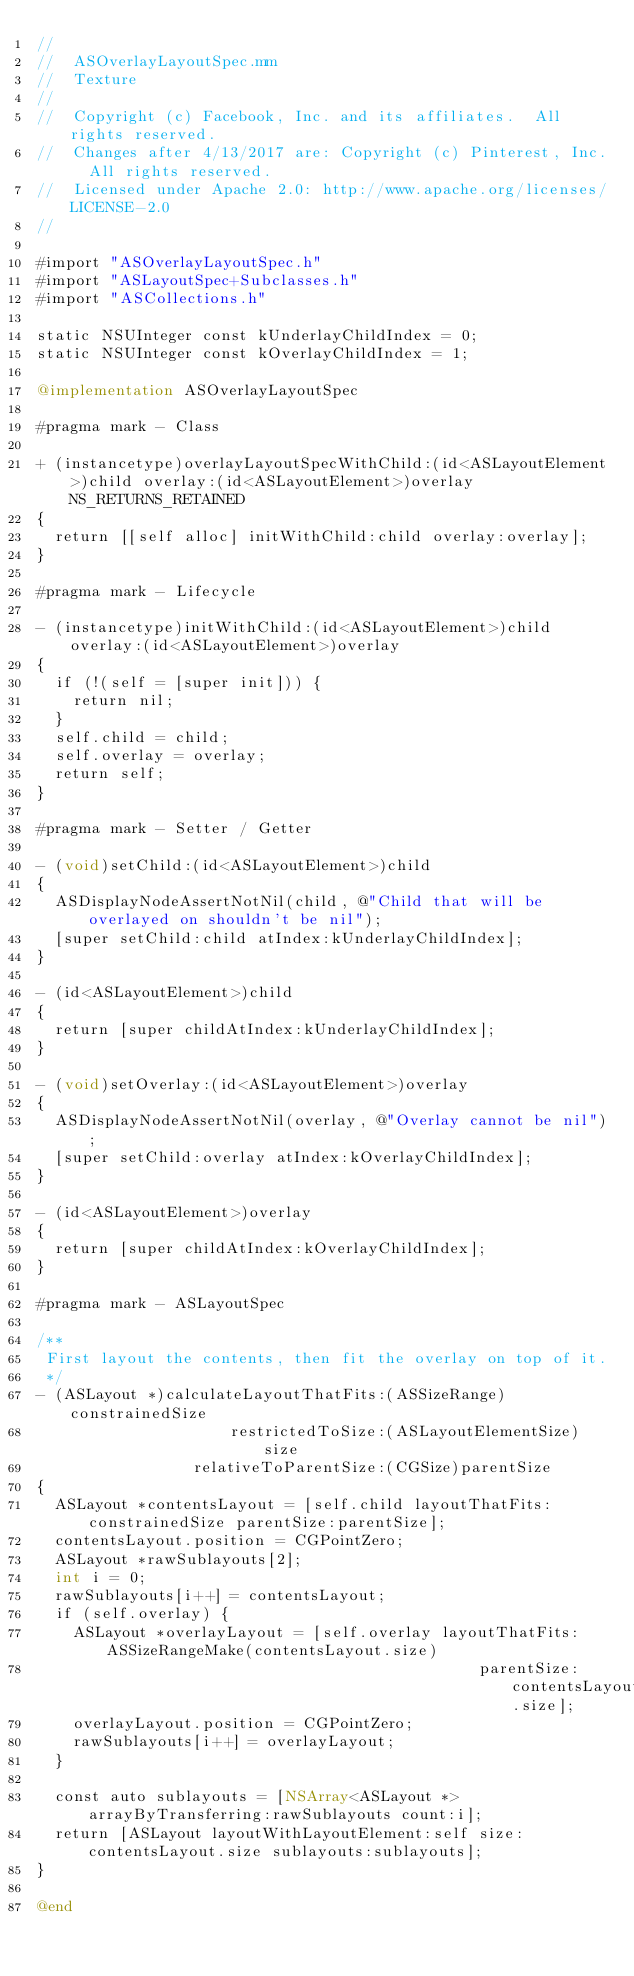<code> <loc_0><loc_0><loc_500><loc_500><_ObjectiveC_>//
//  ASOverlayLayoutSpec.mm
//  Texture
//
//  Copyright (c) Facebook, Inc. and its affiliates.  All rights reserved.
//  Changes after 4/13/2017 are: Copyright (c) Pinterest, Inc.  All rights reserved.
//  Licensed under Apache 2.0: http://www.apache.org/licenses/LICENSE-2.0
//

#import "ASOverlayLayoutSpec.h"
#import "ASLayoutSpec+Subclasses.h"
#import "ASCollections.h"

static NSUInteger const kUnderlayChildIndex = 0;
static NSUInteger const kOverlayChildIndex = 1;

@implementation ASOverlayLayoutSpec

#pragma mark - Class

+ (instancetype)overlayLayoutSpecWithChild:(id<ASLayoutElement>)child overlay:(id<ASLayoutElement>)overlay NS_RETURNS_RETAINED
{
  return [[self alloc] initWithChild:child overlay:overlay];
}

#pragma mark - Lifecycle

- (instancetype)initWithChild:(id<ASLayoutElement>)child overlay:(id<ASLayoutElement>)overlay
{
  if (!(self = [super init])) {
    return nil;
  }
  self.child = child;
  self.overlay = overlay;
  return self;
}

#pragma mark - Setter / Getter

- (void)setChild:(id<ASLayoutElement>)child
{
  ASDisplayNodeAssertNotNil(child, @"Child that will be overlayed on shouldn't be nil");
  [super setChild:child atIndex:kUnderlayChildIndex];
}

- (id<ASLayoutElement>)child
{
  return [super childAtIndex:kUnderlayChildIndex];
}

- (void)setOverlay:(id<ASLayoutElement>)overlay
{
  ASDisplayNodeAssertNotNil(overlay, @"Overlay cannot be nil");
  [super setChild:overlay atIndex:kOverlayChildIndex];
}

- (id<ASLayoutElement>)overlay
{
  return [super childAtIndex:kOverlayChildIndex];
}

#pragma mark - ASLayoutSpec

/**
 First layout the contents, then fit the overlay on top of it.
 */
- (ASLayout *)calculateLayoutThatFits:(ASSizeRange)constrainedSize
                     restrictedToSize:(ASLayoutElementSize)size
                 relativeToParentSize:(CGSize)parentSize
{
  ASLayout *contentsLayout = [self.child layoutThatFits:constrainedSize parentSize:parentSize];
  contentsLayout.position = CGPointZero;
  ASLayout *rawSublayouts[2];
  int i = 0;
  rawSublayouts[i++] = contentsLayout;
  if (self.overlay) {
    ASLayout *overlayLayout = [self.overlay layoutThatFits:ASSizeRangeMake(contentsLayout.size)
                                                parentSize:contentsLayout.size];
    overlayLayout.position = CGPointZero;
    rawSublayouts[i++] = overlayLayout;
  }
  
  const auto sublayouts = [NSArray<ASLayout *> arrayByTransferring:rawSublayouts count:i];
  return [ASLayout layoutWithLayoutElement:self size:contentsLayout.size sublayouts:sublayouts];
}

@end
</code> 